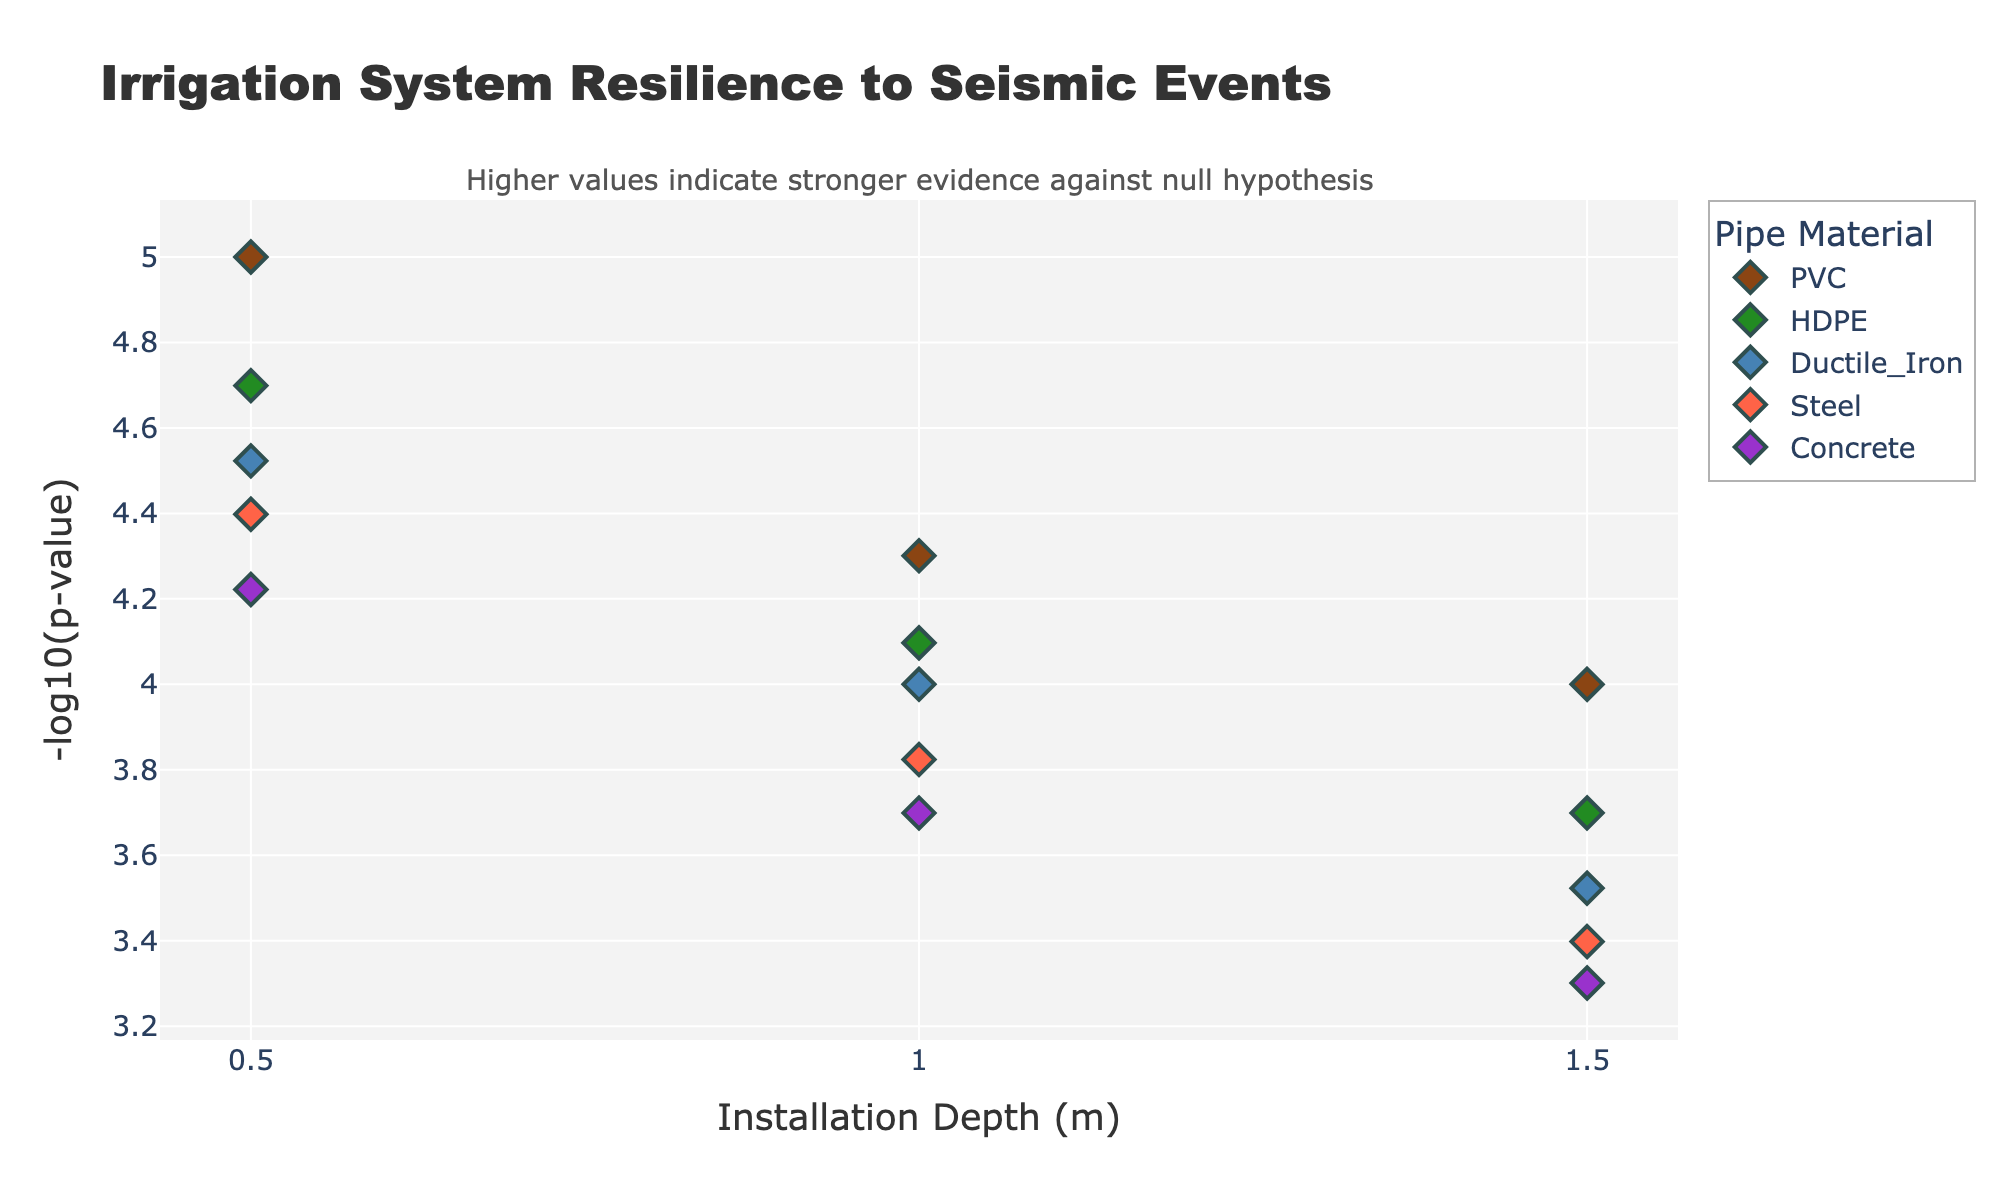What's the title of the figure? The title is located at the top of the figure and provides a high-level summary of what the figure represents. In this case, the title is "Irrigation System Resilience to Seismic Events," which indicates that the figure compares the resilience of various irrigation systems to earthquakes.
Answer: Irrigation System Resilience to Seismic Events What does the y-axis represent? The y-axis is labeled "-log10(p-value)". This means it represents the negative logarithm (base 10) of the p-value, which is used to assess statistical significance. Higher values on this axis indicate stronger evidence against the null hypothesis.
Answer: -log10(p-value) How many different pipe materials are compared in the figure? The legend of the figure lists the different pipe materials. Based on the data, the materials compared are PVC, HDPE, Ductile Iron, Steel, and Concrete.
Answer: 5 Which pipe material has the highest resilience at a depth of 1.5 meters? To find this, look at the markers corresponding to a depth of 1.5 meters across the different materials. The highest value on the y-axis for this depth corresponds to the Steel material, which has the highest resilience score and also the highest -log10(p-value).
Answer: Steel What color represents HDPE pipe material? The figure uses a specific color for each pipe material, shown in the legend. HDPE is represented by the color green.
Answer: Green What is the common trend of resilience (in terms of -log10(p-value)) as the depth increases for most pipe materials? The common trend can be observed by looking at the markers for each material at increasing depths. Generally, the -log10(p-value) increases with depth, implying greater resilience at deeper installations for most materials.
Answer: Increases At a depth of 0.5 meters, which material has the lowest resilience based on -log10(p-value)? By looking at the markers at a depth of 0.5 meters, the material with the lowest resilience (lowest -log10(p-value)) is PVC.
Answer: PVC How does the resilience score of Concrete pipes at 1.0 meters depth compare to that of Steel pipes at the same depth? Look at the -log10(p-value) for Concrete and Steel at 1.0 meters depth. The figure shows that Steel has a higher -log10(p-value) compared to Concrete, indicating better resilience.
Answer: Steel has higher resilience What is the resilience score (in -log10(p-value)) of PVC at 1.5 meters depth? The marker for PVC at a depth of 1.5 meters gives the -log10(p-value). According to the figure, this value is around 4.
Answer: 4 Which material shows the most significant change in resilience (-log10(p-value)) from 0.5 to 1.5 meters depth? To determine this, calculate the difference in -log10(p-value) for each material from 0.5 to 1.5 meters. Steel shows the most significant increase in resilience, as the values go from about 4.9 to 6.2.
Answer: Steel 